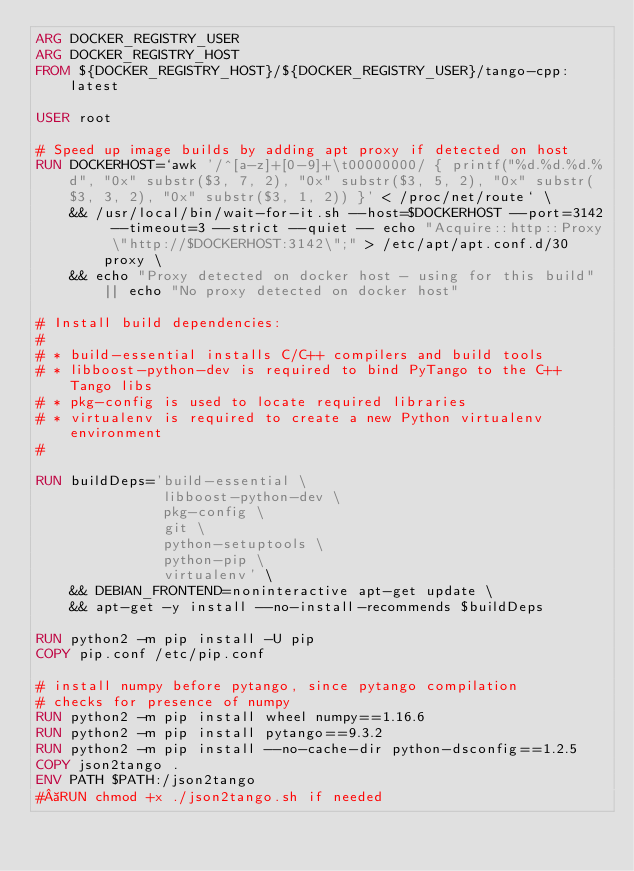<code> <loc_0><loc_0><loc_500><loc_500><_Dockerfile_>ARG DOCKER_REGISTRY_USER
ARG DOCKER_REGISTRY_HOST
FROM ${DOCKER_REGISTRY_HOST}/${DOCKER_REGISTRY_USER}/tango-cpp:latest

USER root

# Speed up image builds by adding apt proxy if detected on host
RUN DOCKERHOST=`awk '/^[a-z]+[0-9]+\t00000000/ { printf("%d.%d.%d.%d", "0x" substr($3, 7, 2), "0x" substr($3, 5, 2), "0x" substr($3, 3, 2), "0x" substr($3, 1, 2)) }' < /proc/net/route` \
    && /usr/local/bin/wait-for-it.sh --host=$DOCKERHOST --port=3142 --timeout=3 --strict --quiet -- echo "Acquire::http::Proxy \"http://$DOCKERHOST:3142\";" > /etc/apt/apt.conf.d/30proxy \
    && echo "Proxy detected on docker host - using for this build" || echo "No proxy detected on docker host"

# Install build dependencies:
#
# * build-essential installs C/C++ compilers and build tools
# * libboost-python-dev is required to bind PyTango to the C++ Tango libs
# * pkg-config is used to locate required libraries
# * virtualenv is required to create a new Python virtualenv environment
#

RUN buildDeps='build-essential \
               libboost-python-dev \
               pkg-config \
               git \
               python-setuptools \
               python-pip \
               virtualenv' \
    && DEBIAN_FRONTEND=noninteractive apt-get update \
    && apt-get -y install --no-install-recommends $buildDeps

RUN python2 -m pip install -U pip
COPY pip.conf /etc/pip.conf

# install numpy before pytango, since pytango compilation
# checks for presence of numpy
RUN python2 -m pip install wheel numpy==1.16.6
RUN python2 -m pip install pytango==9.3.2
RUN python2 -m pip install --no-cache-dir python-dsconfig==1.2.5
COPY json2tango .
ENV PATH $PATH:/json2tango
# RUN chmod +x ./json2tango.sh if needed
</code> 